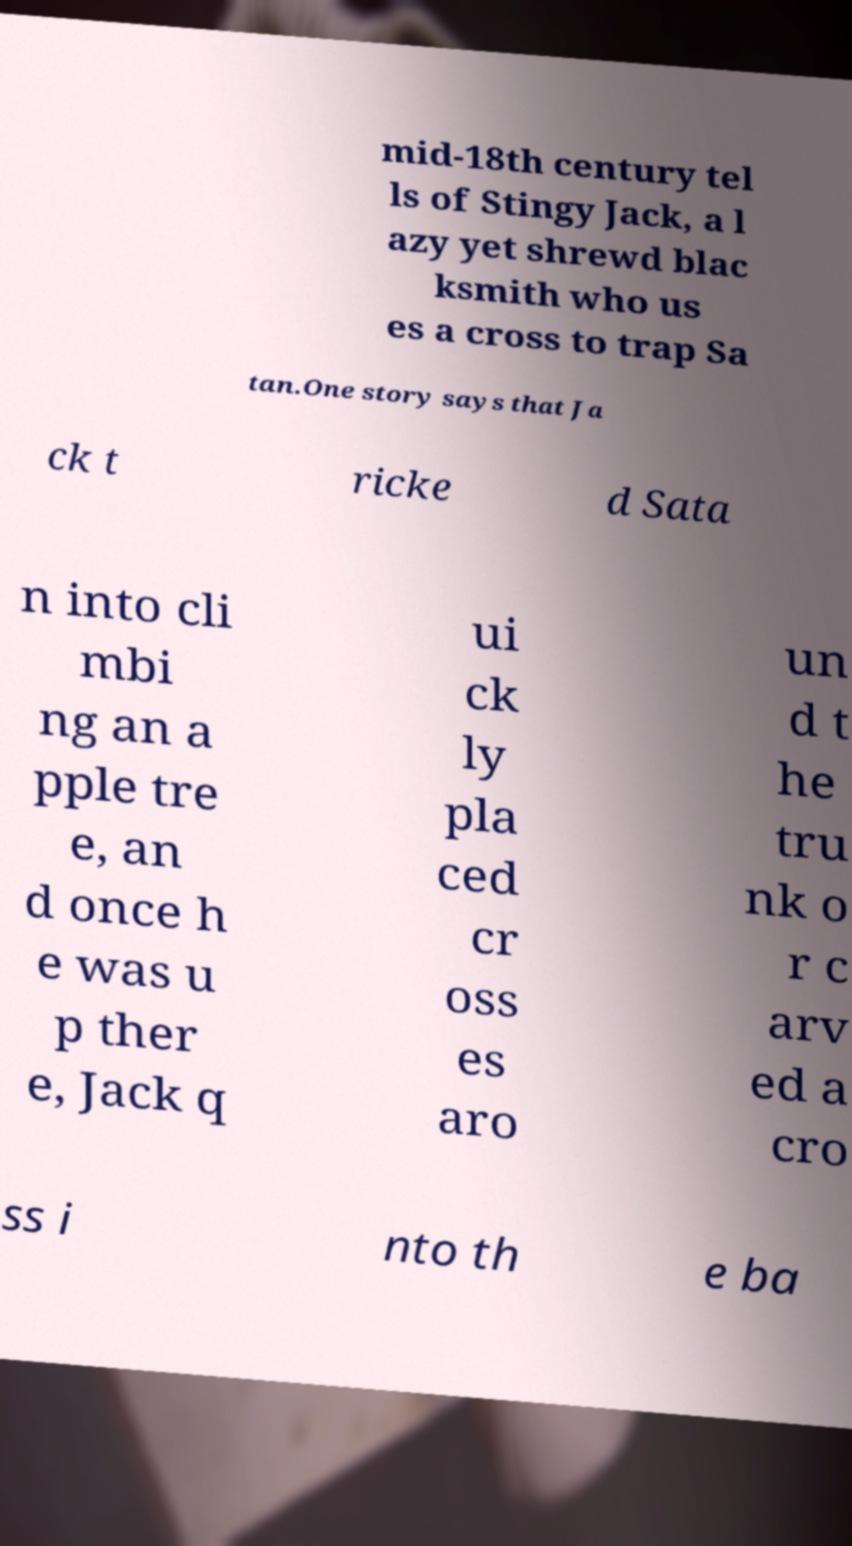Please read and relay the text visible in this image. What does it say? mid-18th century tel ls of Stingy Jack, a l azy yet shrewd blac ksmith who us es a cross to trap Sa tan.One story says that Ja ck t ricke d Sata n into cli mbi ng an a pple tre e, an d once h e was u p ther e, Jack q ui ck ly pla ced cr oss es aro un d t he tru nk o r c arv ed a cro ss i nto th e ba 